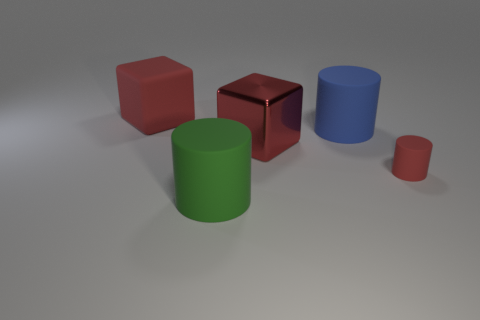Add 3 large red matte things. How many objects exist? 8 Subtract all cylinders. How many objects are left? 2 Subtract all small red matte things. Subtract all rubber things. How many objects are left? 0 Add 4 green rubber cylinders. How many green rubber cylinders are left? 5 Add 4 tiny yellow rubber things. How many tiny yellow rubber things exist? 4 Subtract 0 gray balls. How many objects are left? 5 